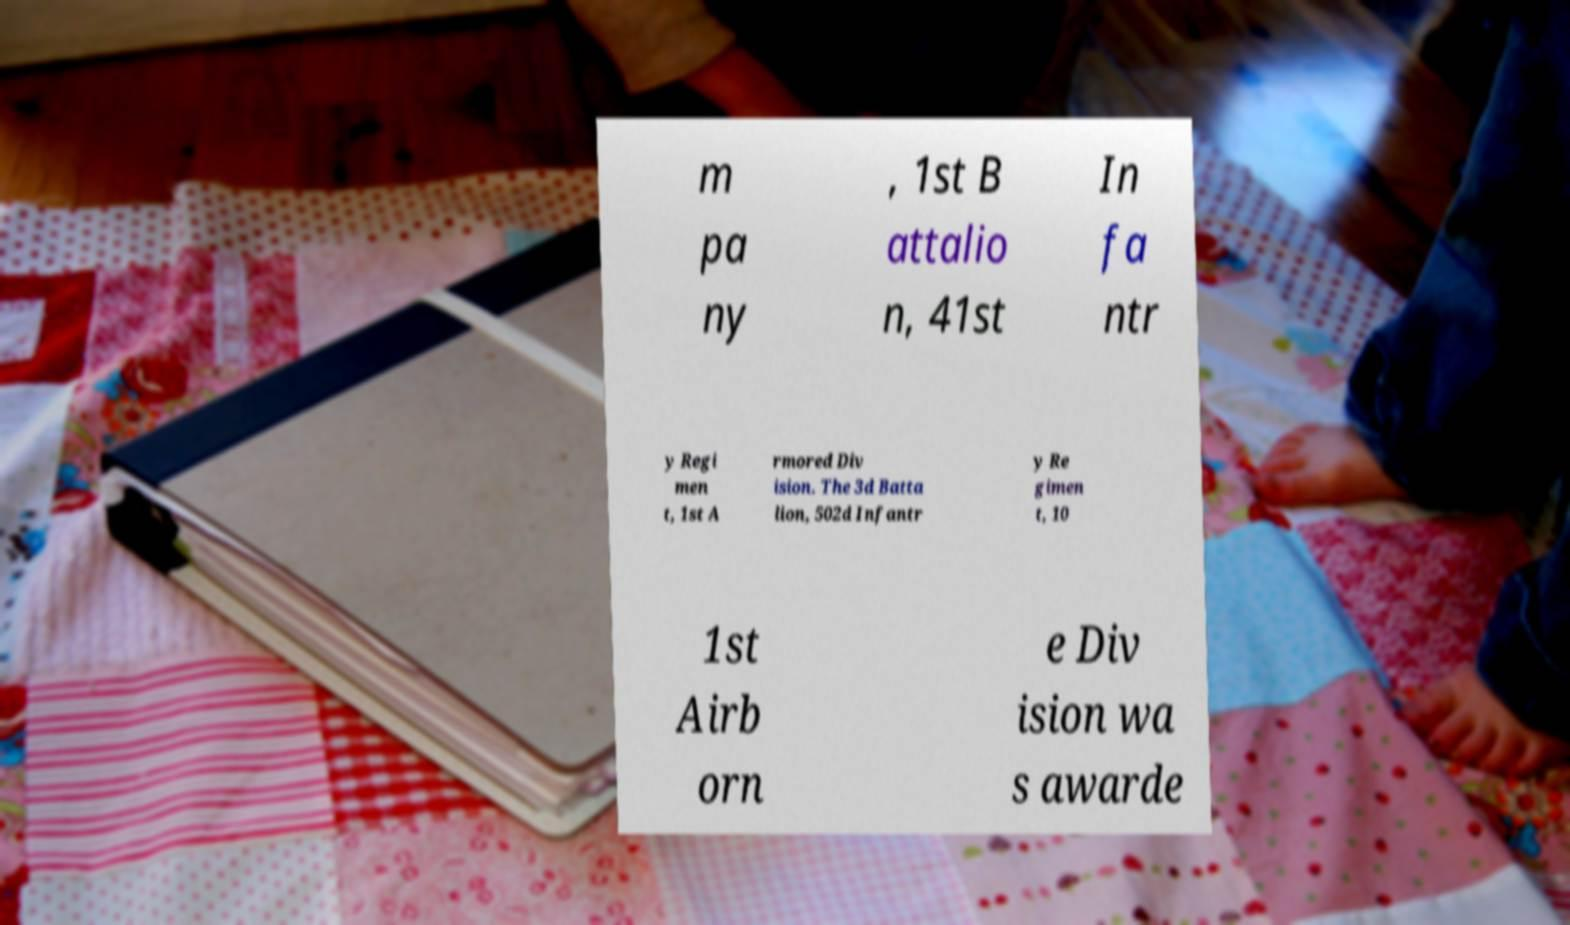For documentation purposes, I need the text within this image transcribed. Could you provide that? m pa ny , 1st B attalio n, 41st In fa ntr y Regi men t, 1st A rmored Div ision. The 3d Batta lion, 502d Infantr y Re gimen t, 10 1st Airb orn e Div ision wa s awarde 